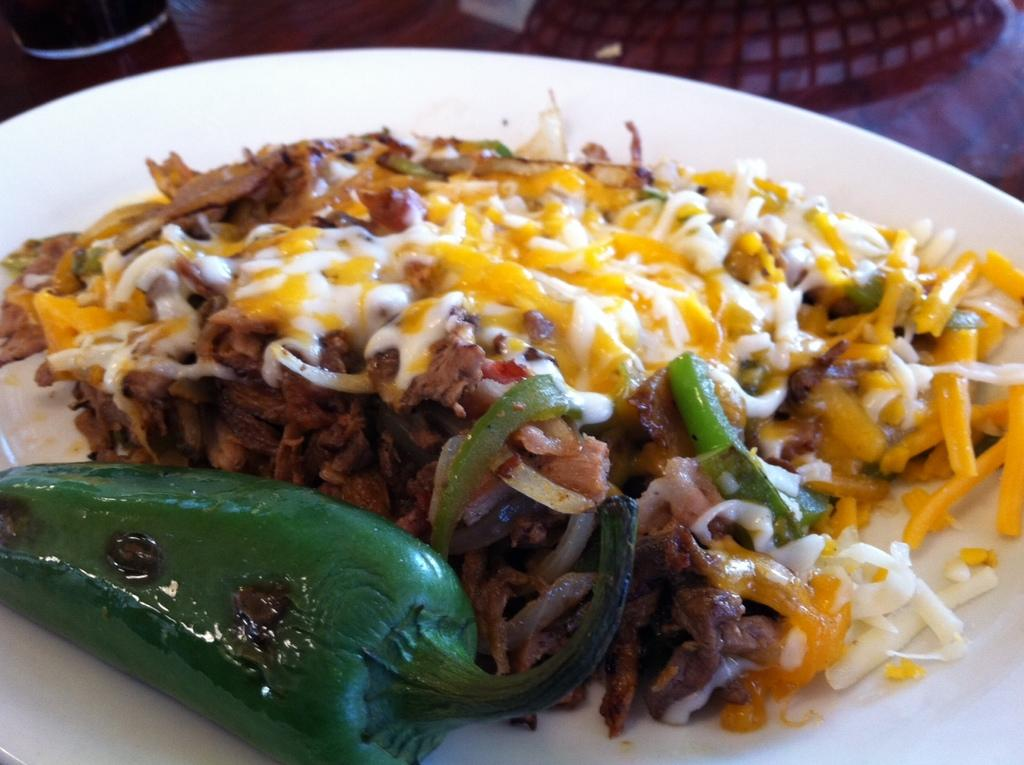What is on the plate can be seen in the image? There are food items in a plate in the image. What else is visible in the image besides the plate? There is a glass in the image. Can you describe the unspecified object on the table? The facts do not provide enough information to describe the unspecified object on the table. What type of setting is the image likely taken in? The image is likely taken in a room. What type of toothpaste is being used in the image? There is no toothpaste present in the image. How many competitors are participating in the competition in the image? There is no competition present in the image. 